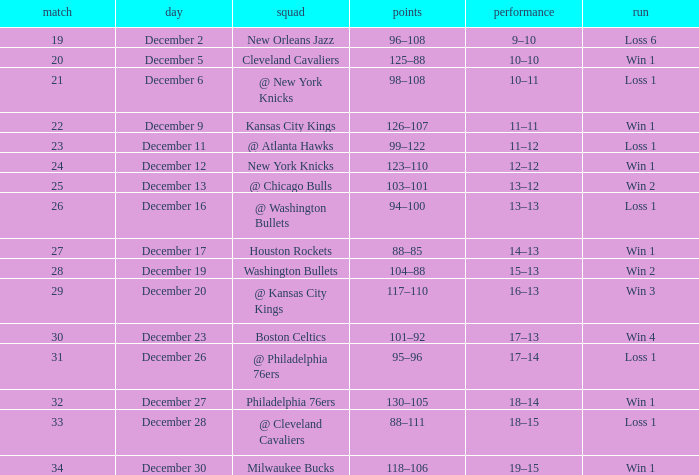What is the Streak on December 30? Win 1. 